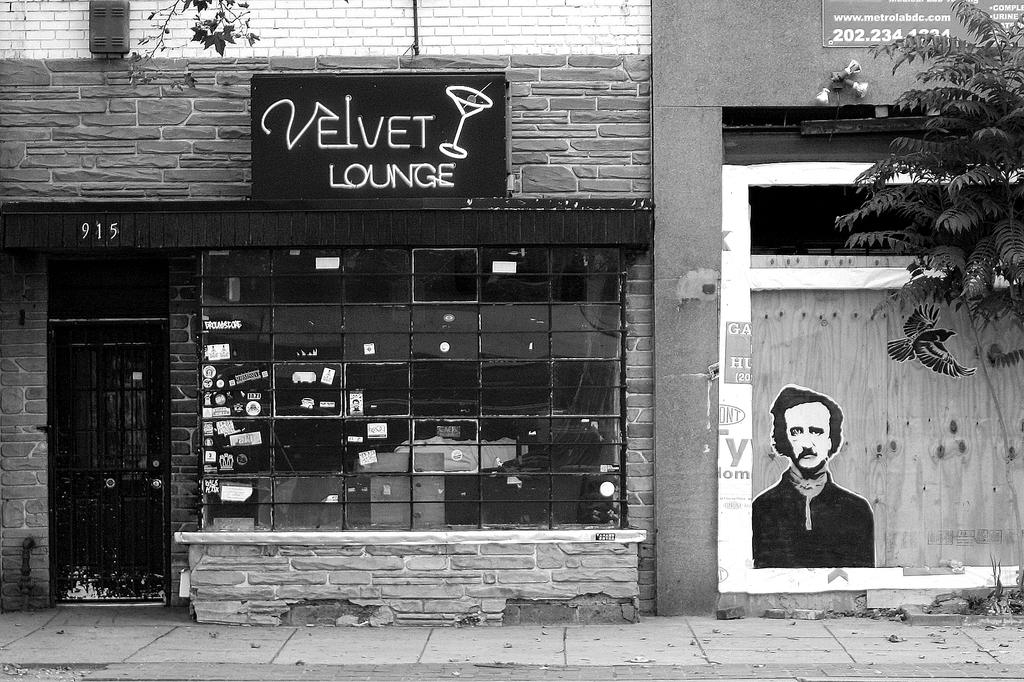What type of structures can be seen in the image? There are buildings in the image. What is attached to one of the buildings? There is a poster in the image. What is a possible entrance in the image? There is a gate in the image. What allows light and air into the building? There is a window in the image. What type of vegetation is present in the image? There is a tree in the image. What type of tub can be seen in the image? There is no tub present in the image. What color is the marble on the tree in the image? There is no marble on the tree in the image; it is a natural tree. 